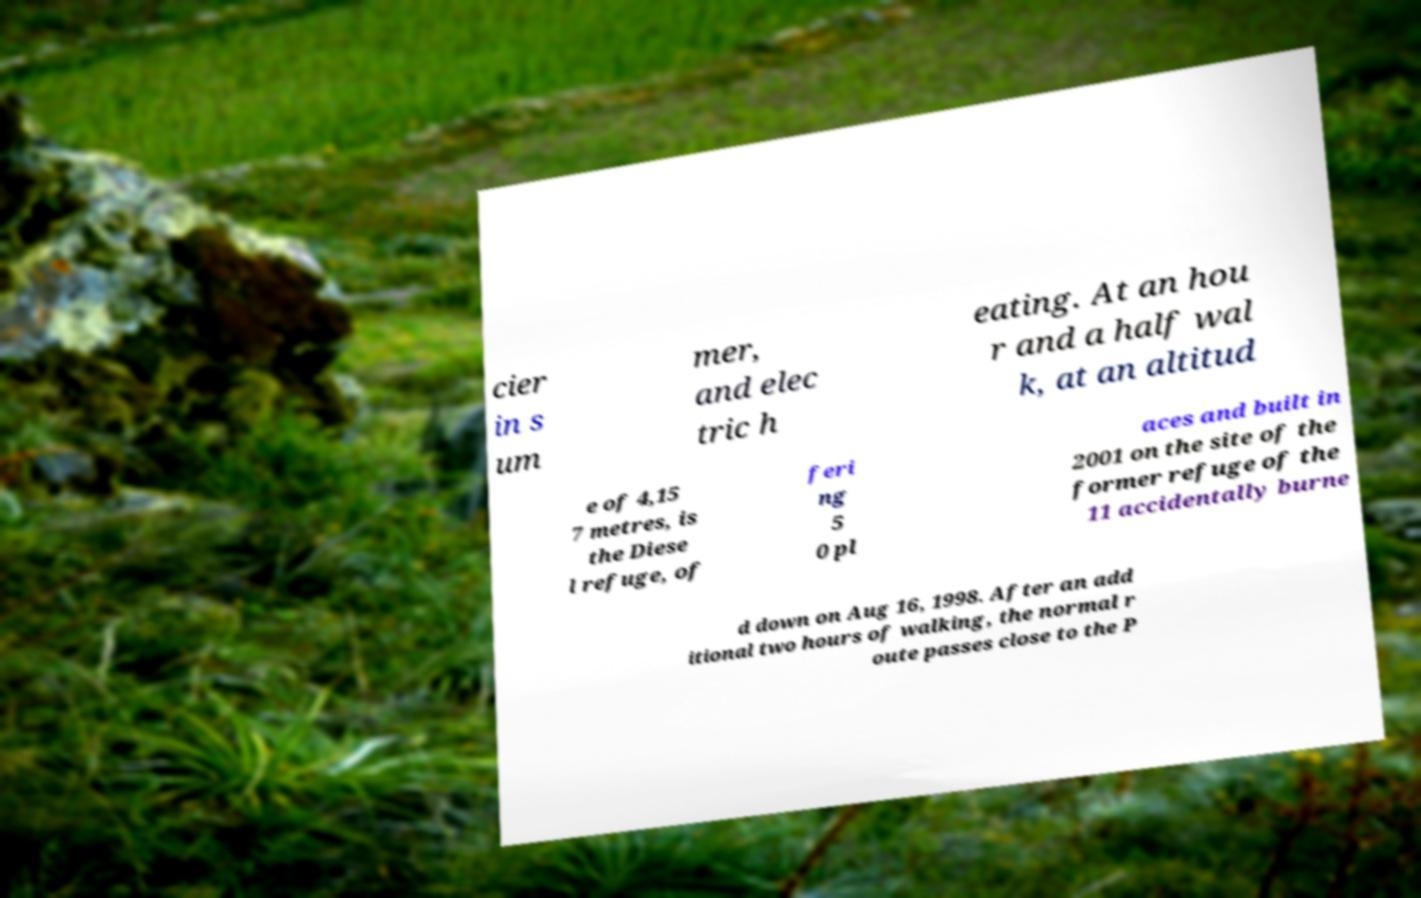Can you accurately transcribe the text from the provided image for me? cier in s um mer, and elec tric h eating. At an hou r and a half wal k, at an altitud e of 4,15 7 metres, is the Diese l refuge, of feri ng 5 0 pl aces and built in 2001 on the site of the former refuge of the 11 accidentally burne d down on Aug 16, 1998. After an add itional two hours of walking, the normal r oute passes close to the P 